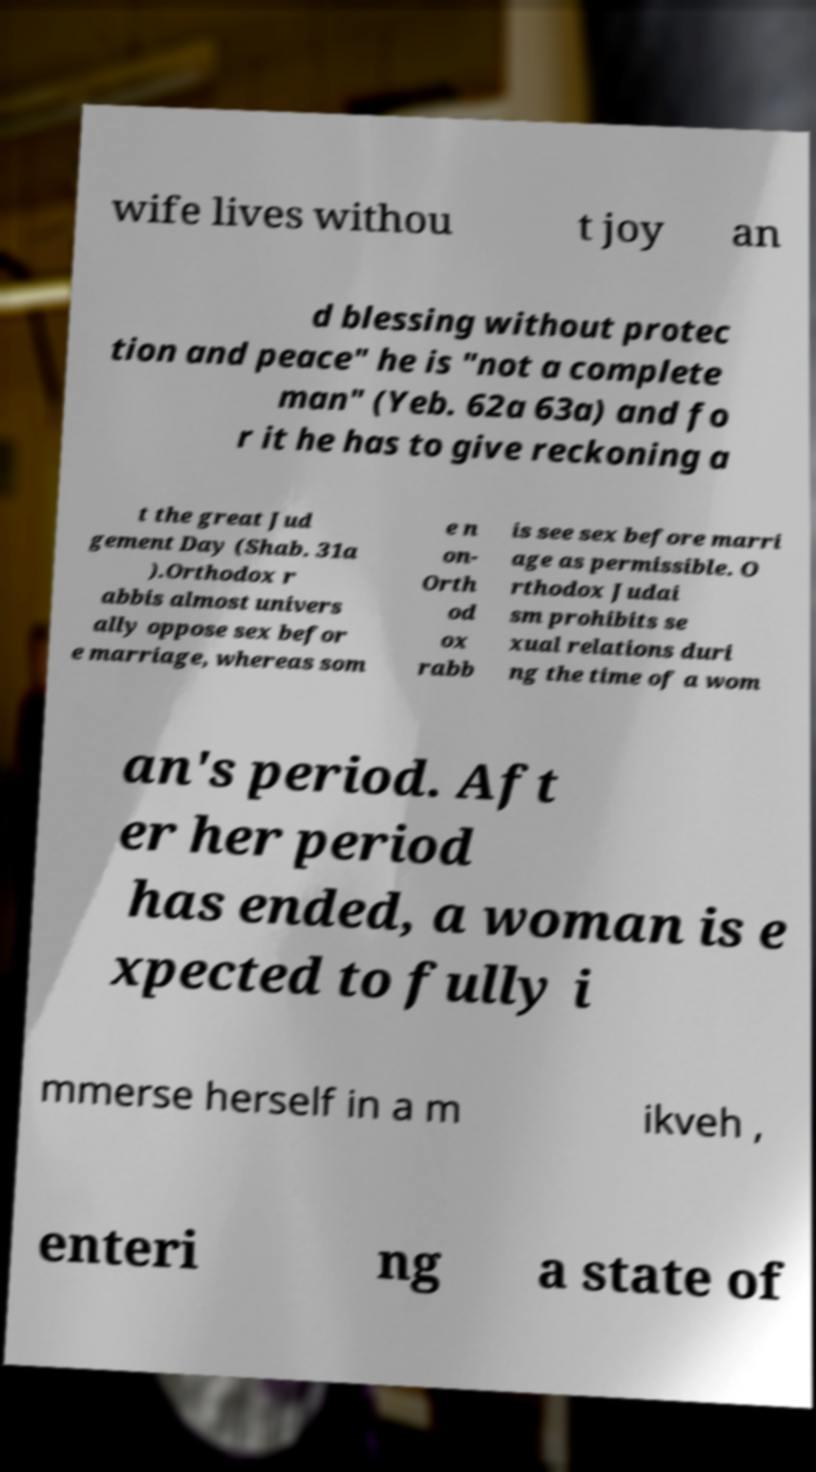I need the written content from this picture converted into text. Can you do that? wife lives withou t joy an d blessing without protec tion and peace" he is "not a complete man" (Yeb. 62a 63a) and fo r it he has to give reckoning a t the great Jud gement Day (Shab. 31a ).Orthodox r abbis almost univers ally oppose sex befor e marriage, whereas som e n on- Orth od ox rabb is see sex before marri age as permissible. O rthodox Judai sm prohibits se xual relations duri ng the time of a wom an's period. Aft er her period has ended, a woman is e xpected to fully i mmerse herself in a m ikveh , enteri ng a state of 